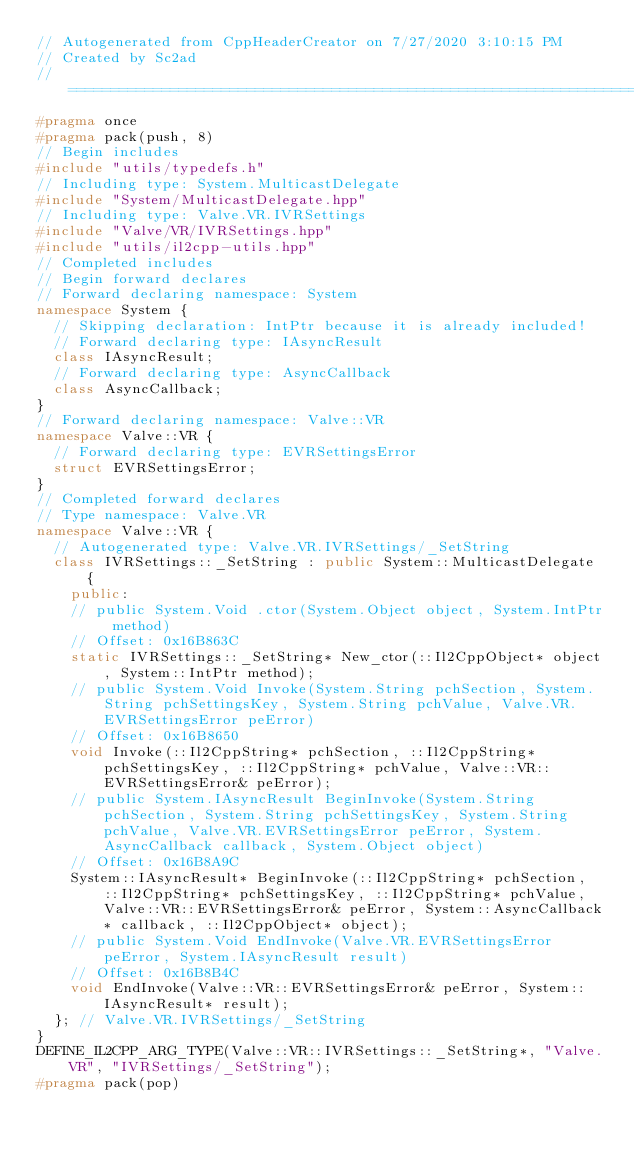Convert code to text. <code><loc_0><loc_0><loc_500><loc_500><_C++_>// Autogenerated from CppHeaderCreator on 7/27/2020 3:10:15 PM
// Created by Sc2ad
// =========================================================================
#pragma once
#pragma pack(push, 8)
// Begin includes
#include "utils/typedefs.h"
// Including type: System.MulticastDelegate
#include "System/MulticastDelegate.hpp"
// Including type: Valve.VR.IVRSettings
#include "Valve/VR/IVRSettings.hpp"
#include "utils/il2cpp-utils.hpp"
// Completed includes
// Begin forward declares
// Forward declaring namespace: System
namespace System {
  // Skipping declaration: IntPtr because it is already included!
  // Forward declaring type: IAsyncResult
  class IAsyncResult;
  // Forward declaring type: AsyncCallback
  class AsyncCallback;
}
// Forward declaring namespace: Valve::VR
namespace Valve::VR {
  // Forward declaring type: EVRSettingsError
  struct EVRSettingsError;
}
// Completed forward declares
// Type namespace: Valve.VR
namespace Valve::VR {
  // Autogenerated type: Valve.VR.IVRSettings/_SetString
  class IVRSettings::_SetString : public System::MulticastDelegate {
    public:
    // public System.Void .ctor(System.Object object, System.IntPtr method)
    // Offset: 0x16B863C
    static IVRSettings::_SetString* New_ctor(::Il2CppObject* object, System::IntPtr method);
    // public System.Void Invoke(System.String pchSection, System.String pchSettingsKey, System.String pchValue, Valve.VR.EVRSettingsError peError)
    // Offset: 0x16B8650
    void Invoke(::Il2CppString* pchSection, ::Il2CppString* pchSettingsKey, ::Il2CppString* pchValue, Valve::VR::EVRSettingsError& peError);
    // public System.IAsyncResult BeginInvoke(System.String pchSection, System.String pchSettingsKey, System.String pchValue, Valve.VR.EVRSettingsError peError, System.AsyncCallback callback, System.Object object)
    // Offset: 0x16B8A9C
    System::IAsyncResult* BeginInvoke(::Il2CppString* pchSection, ::Il2CppString* pchSettingsKey, ::Il2CppString* pchValue, Valve::VR::EVRSettingsError& peError, System::AsyncCallback* callback, ::Il2CppObject* object);
    // public System.Void EndInvoke(Valve.VR.EVRSettingsError peError, System.IAsyncResult result)
    // Offset: 0x16B8B4C
    void EndInvoke(Valve::VR::EVRSettingsError& peError, System::IAsyncResult* result);
  }; // Valve.VR.IVRSettings/_SetString
}
DEFINE_IL2CPP_ARG_TYPE(Valve::VR::IVRSettings::_SetString*, "Valve.VR", "IVRSettings/_SetString");
#pragma pack(pop)
</code> 